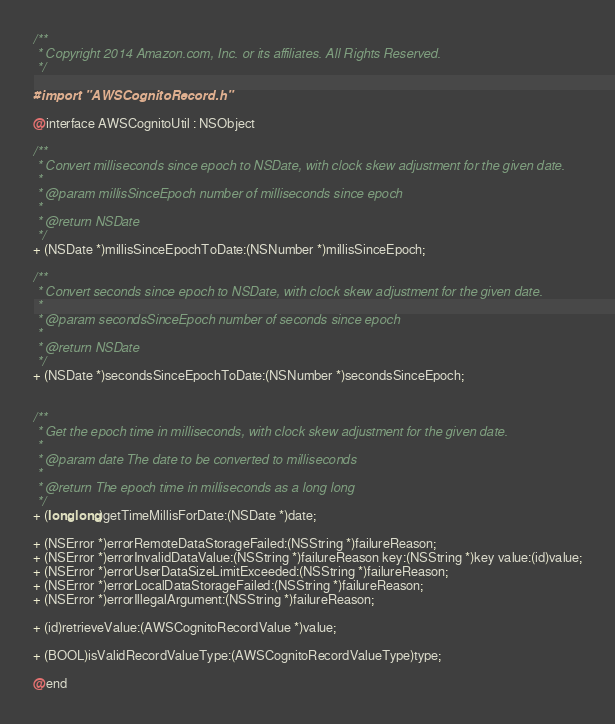Convert code to text. <code><loc_0><loc_0><loc_500><loc_500><_C_>/**
 * Copyright 2014 Amazon.com, Inc. or its affiliates. All Rights Reserved.
 */

#import "AWSCognitoRecord.h"

@interface AWSCognitoUtil : NSObject

/**
 * Convert milliseconds since epoch to NSDate, with clock skew adjustment for the given date.
 *
 * @param millisSinceEpoch number of milliseconds since epoch
 *
 * @return NSDate
 */
+ (NSDate *)millisSinceEpochToDate:(NSNumber *)millisSinceEpoch;

/**
 * Convert seconds since epoch to NSDate, with clock skew adjustment for the given date.
 *
 * @param secondsSinceEpoch number of seconds since epoch
 *
 * @return NSDate
 */
+ (NSDate *)secondsSinceEpochToDate:(NSNumber *)secondsSinceEpoch;


/**
 * Get the epoch time in milliseconds, with clock skew adjustment for the given date.
 *
 * @param date The date to be converted to milliseconds 
 * 
 * @return The epoch time in milliseconds as a long long
 */
+ (long long)getTimeMillisForDate:(NSDate *)date;

+ (NSError *)errorRemoteDataStorageFailed:(NSString *)failureReason;
+ (NSError *)errorInvalidDataValue:(NSString *)failureReason key:(NSString *)key value:(id)value;
+ (NSError *)errorUserDataSizeLimitExceeded:(NSString *)failureReason;
+ (NSError *)errorLocalDataStorageFailed:(NSString *)failureReason;
+ (NSError *)errorIllegalArgument:(NSString *)failureReason;

+ (id)retrieveValue:(AWSCognitoRecordValue *)value;

+ (BOOL)isValidRecordValueType:(AWSCognitoRecordValueType)type;

@end
</code> 